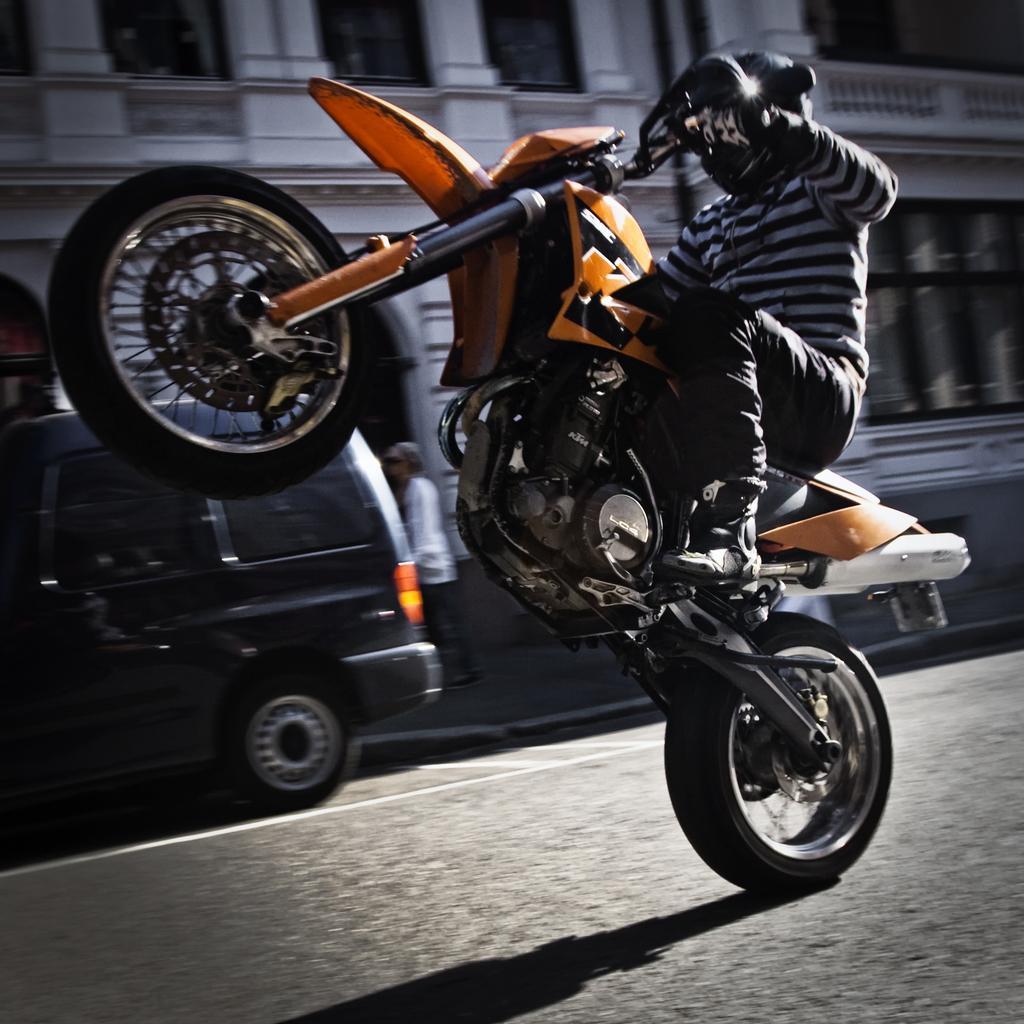Please provide a concise description of this image. This person is lifting his motorcycle and riding. We can able to see building, vehicle and a person is standing. 